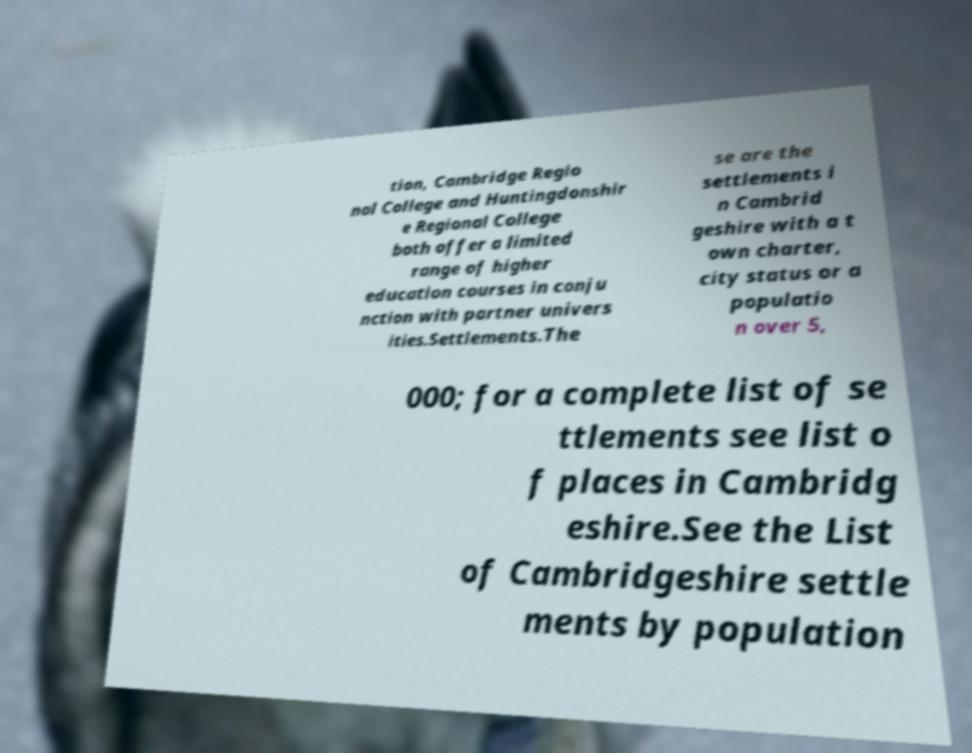Please read and relay the text visible in this image. What does it say? tion, Cambridge Regio nal College and Huntingdonshir e Regional College both offer a limited range of higher education courses in conju nction with partner univers ities.Settlements.The se are the settlements i n Cambrid geshire with a t own charter, city status or a populatio n over 5, 000; for a complete list of se ttlements see list o f places in Cambridg eshire.See the List of Cambridgeshire settle ments by population 